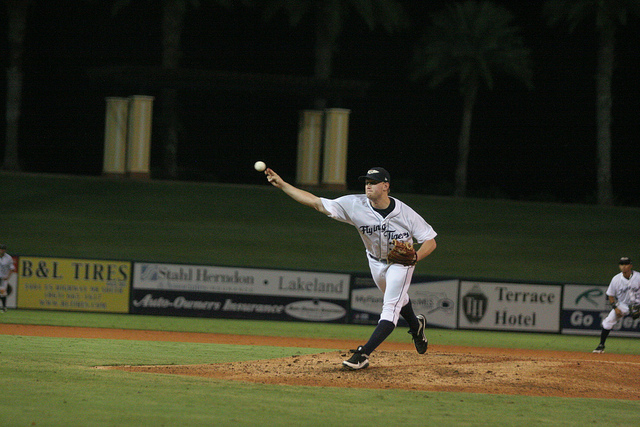<image>Who sponsors this baseball team? I am not sure who sponsors this baseball team. It could be 'b&l tires' or 'terrace hotel'. What is written on the white shirt? I am not sure what is written on the white shirt. It could be 'flying', 'flying tigers', 'royal', or 'pirates'. Who sponsors this baseball team? I don't know who sponsors this baseball team. It could be either B&L Tires or Terrace Hotel. What is written on the white shirt? I don't know what is written on the white shirt. It can be 'flying', 'flying tigers', 'royal', 'pirates', or 'flying moons'. 